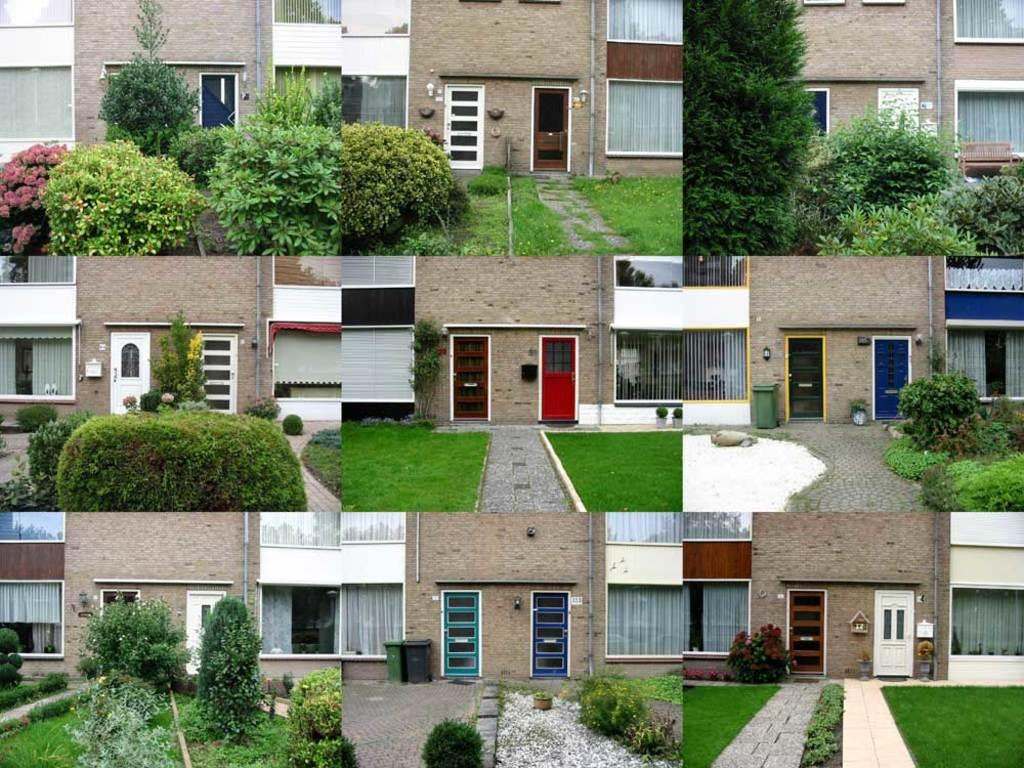What type of vegetation can be seen in the image? There are plants, grass, and trees in the image. What type of structures are present in the image? There are buildings in the image. What architectural features can be seen in the image? There are walls, windows, and doors in the image. What type of waste disposal containers are visible in the image? There are dustbins in the image. Can you see your dad at the airport in the image? There is no airport or dad present in the image. What type of cup is being used to water the plants in the image? There is no cup visible in the image, and the plants do not appear to be watered. 